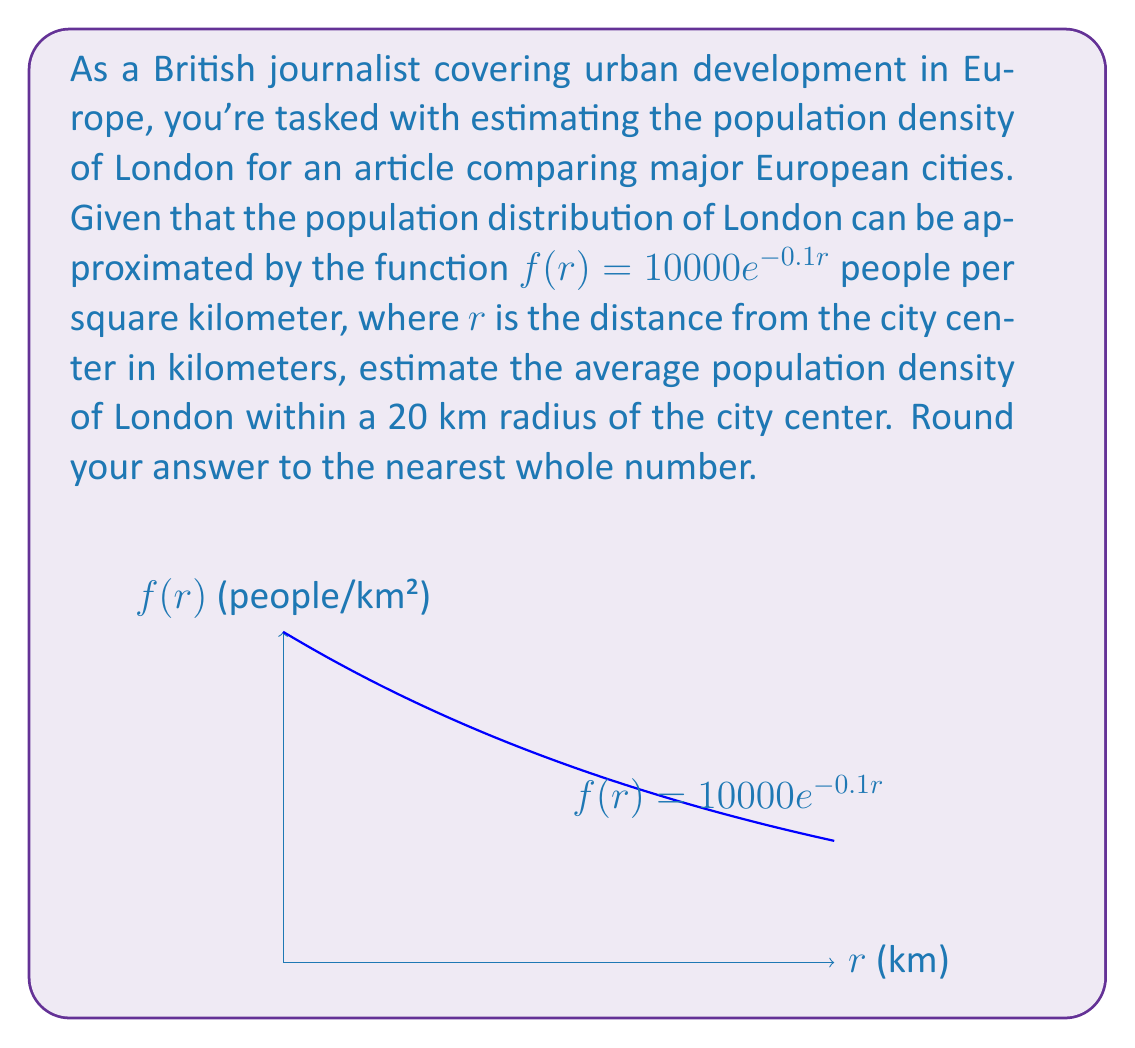Teach me how to tackle this problem. To solve this problem, we need to use integration to find the average population density. Here's a step-by-step approach:

1) The average population density is given by the total population divided by the total area.

2) To find the total population, we need to integrate the population density function over the circular area:

   $$\text{Total Population} = \int_0^{2\pi} \int_0^{20} f(r) \cdot r \, dr \, d\theta$$

3) Since the function is radially symmetric, we can simplify this to:

   $$\text{Total Population} = 2\pi \int_0^{20} 10000e^{-0.1r} \cdot r \, dr$$

4) To solve this integral, we use integration by parts:
   Let $u = r$ and $dv = 10000e^{-0.1r} \, dr$
   Then $du = dr$ and $v = -100000e^{-0.1r}$

   $$2\pi \left[-100000re^{-0.1r}\bigg|_0^{20} + \int_0^{20} 100000e^{-0.1r} \, dr\right]$$

5) Evaluating this:

   $$2\pi \left[-100000(20e^{-2} - 0) - 1000000(e^{-2} - 1)\right]$$

6) The total area is simply $\pi r^2 = \pi (20)^2 = 400\pi$ km²

7) Therefore, the average population density is:

   $$\frac{2\pi \left[-100000(20e^{-2} - 0) - 1000000(e^{-2} - 1)\right]}{400\pi}$$

8) Simplifying and calculating this gives approximately 3,161.72 people per km²

9) Rounding to the nearest whole number gives 3,162 people per km²
Answer: 3,162 people/km² 